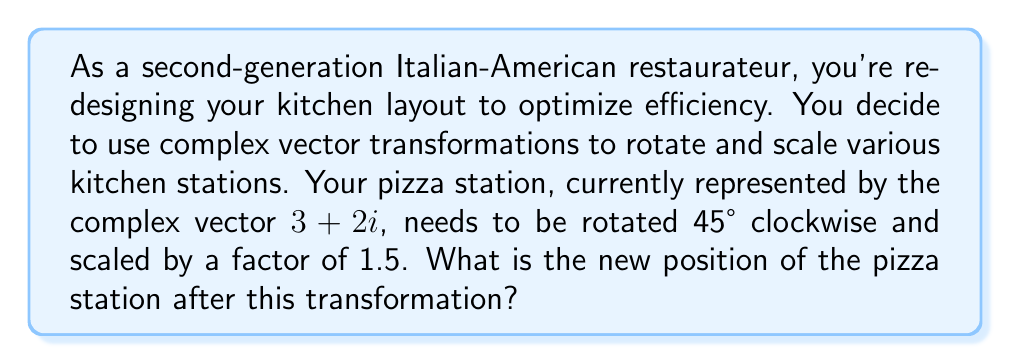Teach me how to tackle this problem. To solve this problem, we'll use complex number operations:

1) First, let's consider the rotation. A rotation of $\theta$ radians clockwise is represented by multiplication with $e^{-i\theta}$. For 45° clockwise:

   $\theta = 45° = \frac{\pi}{4}$ radians
   
   $e^{-i\frac{\pi}{4}} = \cos(-\frac{\pi}{4}) + i\sin(-\frac{\pi}{4}) = \frac{\sqrt{2}}{2} - i\frac{\sqrt{2}}{2}$

2) Next, we need to scale by a factor of 1.5. In complex number operations, scaling is simple multiplication.

3) Let's combine these operations:

   $$(3+2i) \cdot 1.5 \cdot (e^{-i\frac{\pi}{4}})$$
   
   $$= (4.5+3i) \cdot (\frac{\sqrt{2}}{2} - i\frac{\sqrt{2}}{2})$$

4) Multiply these complex numbers:

   $$(4.5+3i) \cdot (\frac{\sqrt{2}}{2} - i\frac{\sqrt{2}}{2})$$
   $$= (4.5 \cdot \frac{\sqrt{2}}{2} + 3 \cdot \frac{\sqrt{2}}{2}) + i(3 \cdot \frac{\sqrt{2}}{2} - 4.5 \cdot \frac{\sqrt{2}}{2})$$
   $$= \frac{4.5\sqrt{2}}{2} + \frac{3\sqrt{2}}{2} + i(\frac{3\sqrt{2}}{2} - \frac{4.5\sqrt{2}}{2})$$
   $$= \frac{7.5\sqrt{2}}{2} + i(\frac{-1.5\sqrt{2}}{2})$$
   $$\approx 5.30 - 1.06i$$

5) Therefore, the new position of the pizza station is approximately $5.30 - 1.06i$.
Answer: $5.30 - 1.06i$ 